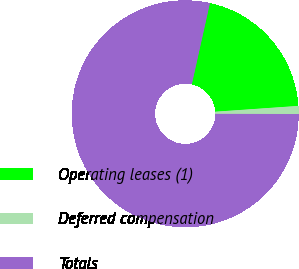Convert chart to OTSL. <chart><loc_0><loc_0><loc_500><loc_500><pie_chart><fcel>Operating leases (1)<fcel>Deferred compensation<fcel>Totals<nl><fcel>20.4%<fcel>1.14%<fcel>78.47%<nl></chart> 